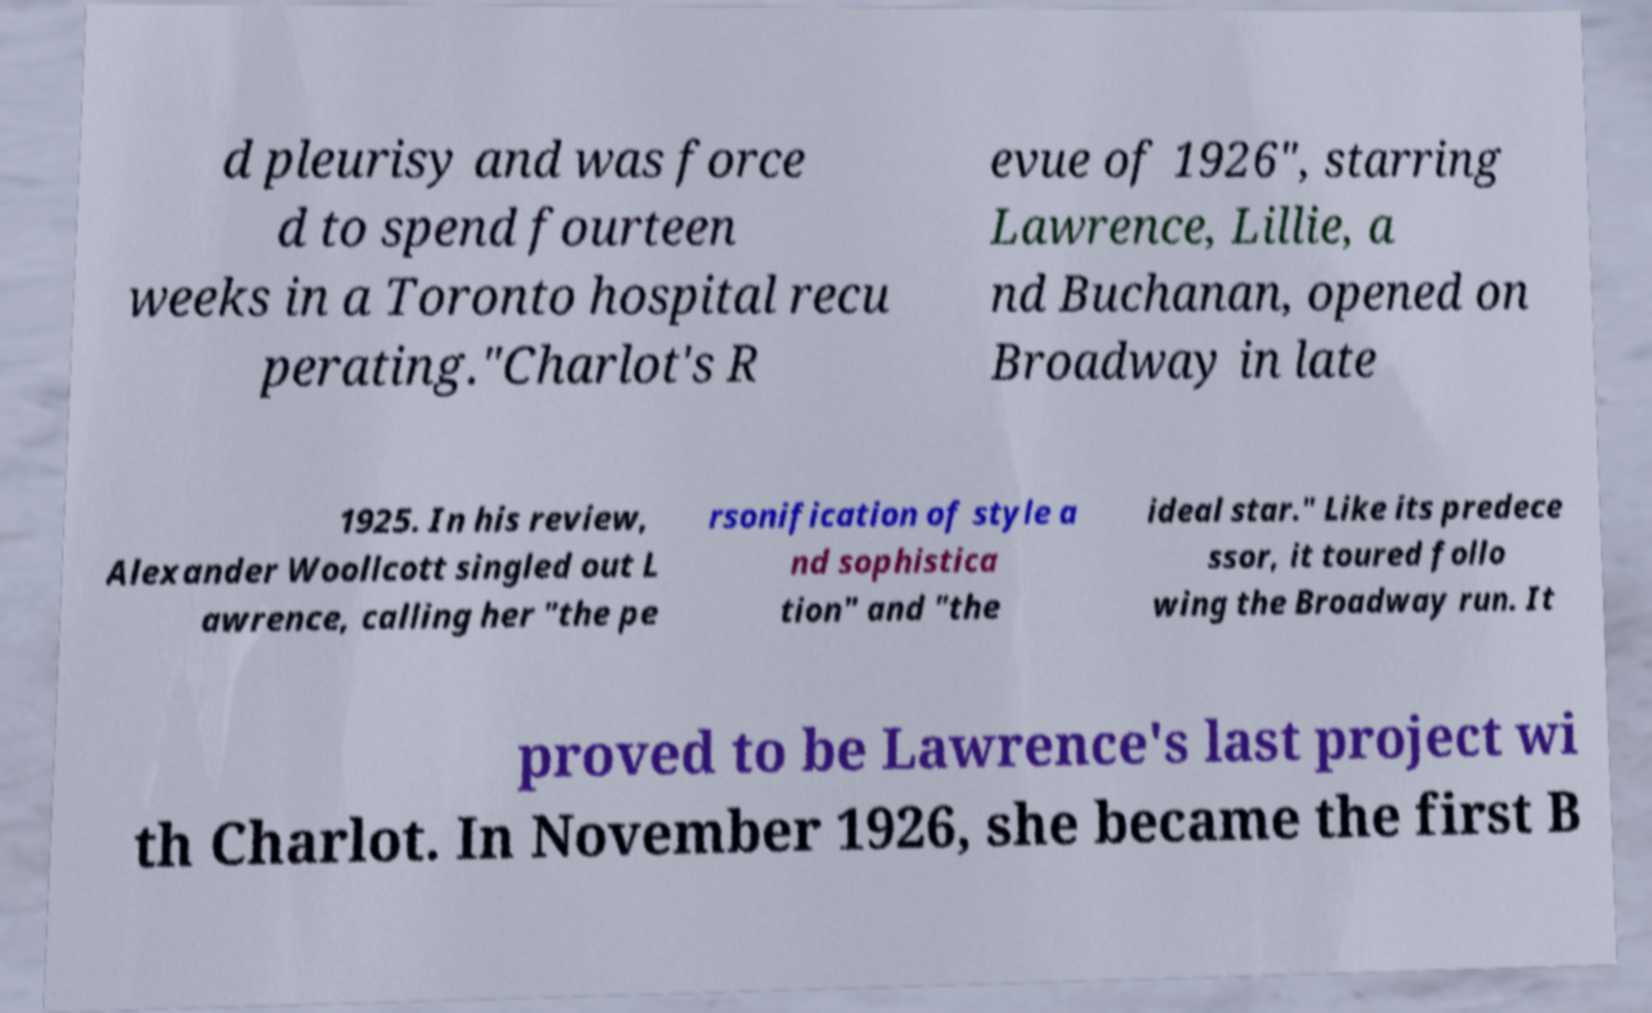Could you assist in decoding the text presented in this image and type it out clearly? d pleurisy and was force d to spend fourteen weeks in a Toronto hospital recu perating."Charlot's R evue of 1926", starring Lawrence, Lillie, a nd Buchanan, opened on Broadway in late 1925. In his review, Alexander Woollcott singled out L awrence, calling her "the pe rsonification of style a nd sophistica tion" and "the ideal star." Like its predece ssor, it toured follo wing the Broadway run. It proved to be Lawrence's last project wi th Charlot. In November 1926, she became the first B 